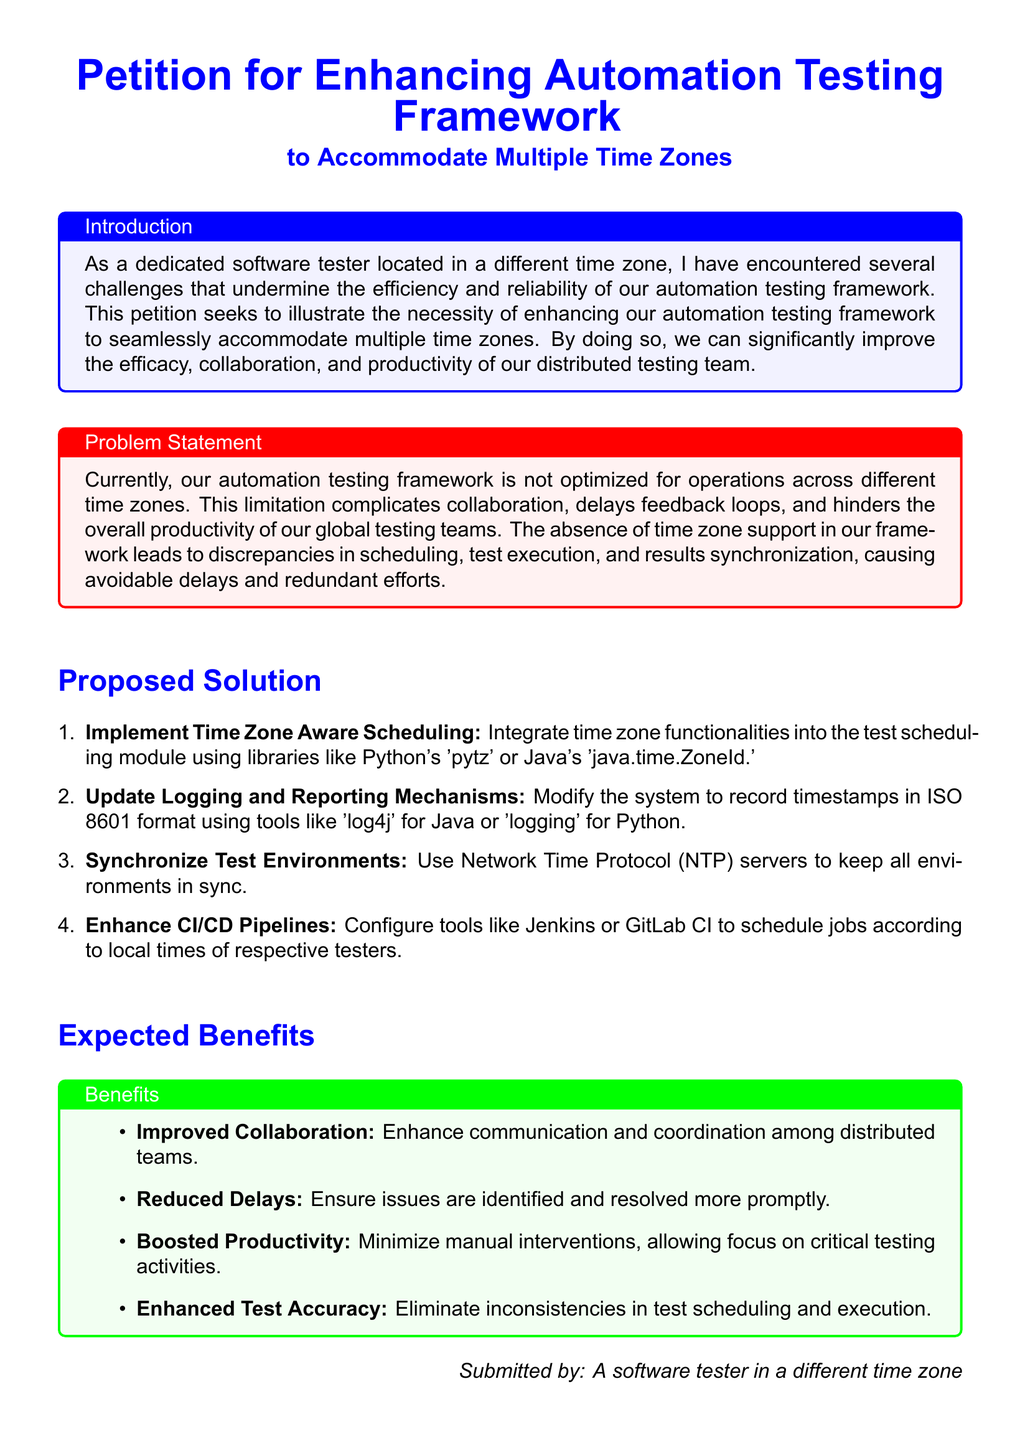What is the title of the petition? The title of the petition is specified at the beginning of the document.
Answer: Petition for Enhancing Automation Testing Framework What issue does the petition address? The problem statement section highlights the main issue the petition is addressing.
Answer: Lack of time zone support What is the first proposed solution? The proposed solutions are listed in an enumerated format, and the first one addresses scheduling.
Answer: Implement Time Zone Aware Scheduling Which libraries are suggested for scheduling? The proposed solution mentions specific libraries for time zone functionalities.
Answer: Python's 'pytz' or Java's 'java.time.ZoneId' What is one expected benefit of the proposed changes? The expected benefits are listed in an itemized format, with each benefit clearly stated.
Answer: Improved Collaboration Who submitted the petition? The last section of the document identifies the individual responsible for the submission.
Answer: A software tester in a different time zone How many proposed solutions are outlined in the document? The number of proposed solutions can be counted from the enumerated list provided.
Answer: Four What format should timestamps be recorded in? The logging and reporting section mentions a specific format for timestamps.
Answer: ISO 8601 format What is one tool recommended for enhancing CI/CD pipelines? The proposed solution mentions specific tools to configure for scheduling jobs.
Answer: Jenkins or GitLab CI 